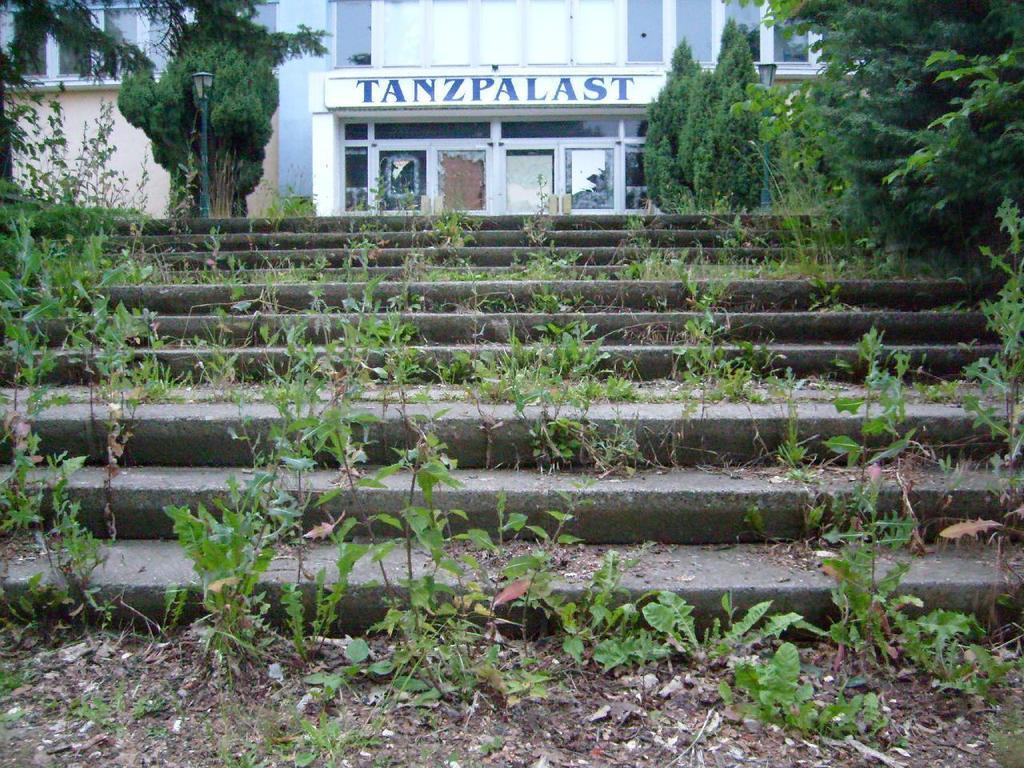Please provide a concise description of this image. In this image I can see a building, in front of building I can see trees, small pants ,staircase , street light pole visible. 